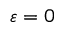<formula> <loc_0><loc_0><loc_500><loc_500>\varepsilon = 0</formula> 